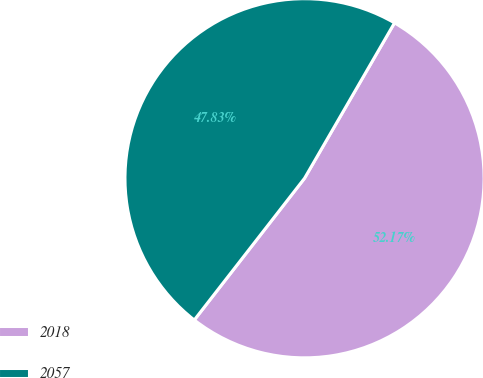Convert chart. <chart><loc_0><loc_0><loc_500><loc_500><pie_chart><fcel>2018<fcel>2057<nl><fcel>52.17%<fcel>47.83%<nl></chart> 